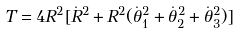Convert formula to latex. <formula><loc_0><loc_0><loc_500><loc_500>T = 4 R ^ { 2 } [ \dot { R } ^ { 2 } + R ^ { 2 } ( \dot { \theta } _ { 1 } ^ { 2 } + \dot { \theta } _ { 2 } ^ { 2 } + \dot { \theta } _ { 3 } ^ { 2 } ) ]</formula> 